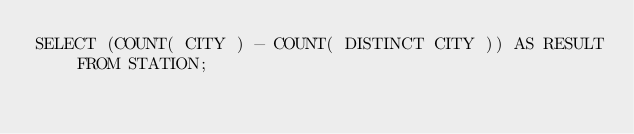<code> <loc_0><loc_0><loc_500><loc_500><_SQL_>SELECT (COUNT( CITY ) - COUNT( DISTINCT CITY )) AS RESULT FROM STATION;
</code> 